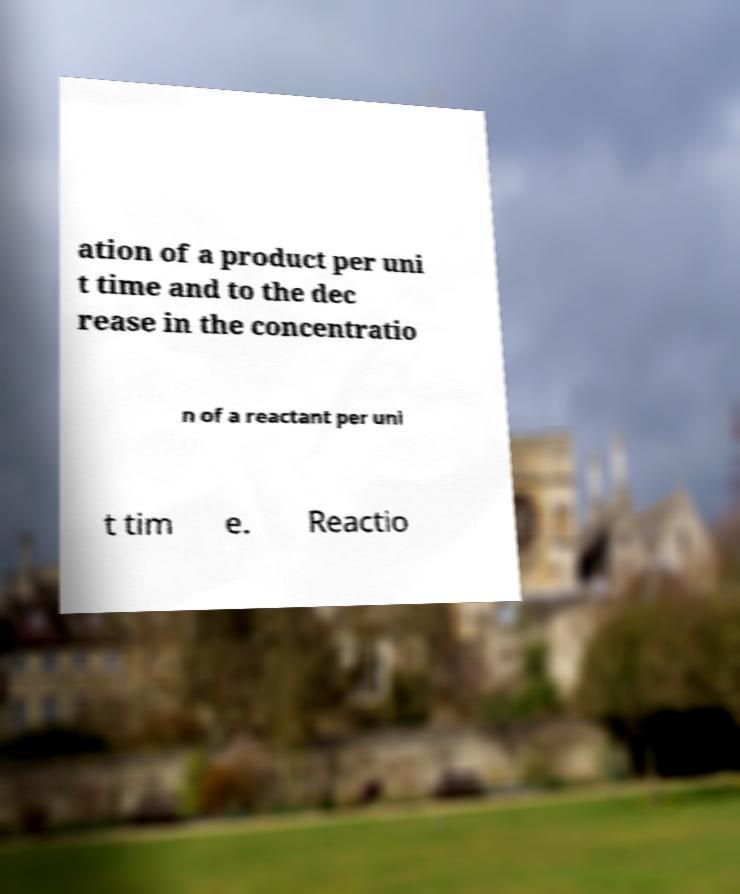Please read and relay the text visible in this image. What does it say? ation of a product per uni t time and to the dec rease in the concentratio n of a reactant per uni t tim e. Reactio 